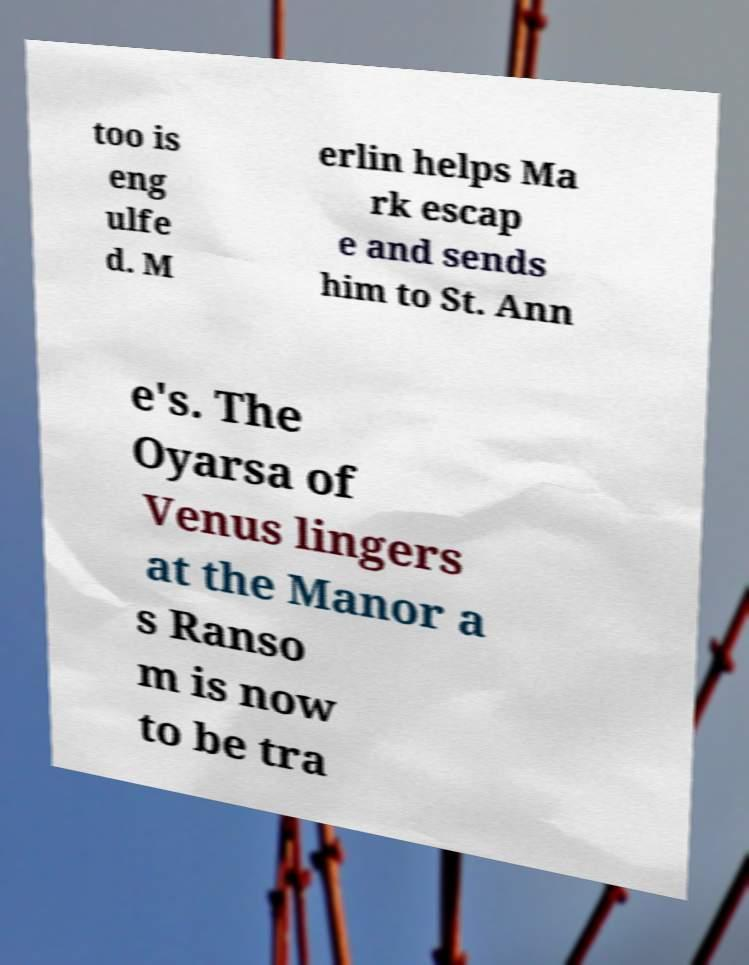I need the written content from this picture converted into text. Can you do that? too is eng ulfe d. M erlin helps Ma rk escap e and sends him to St. Ann e's. The Oyarsa of Venus lingers at the Manor a s Ranso m is now to be tra 